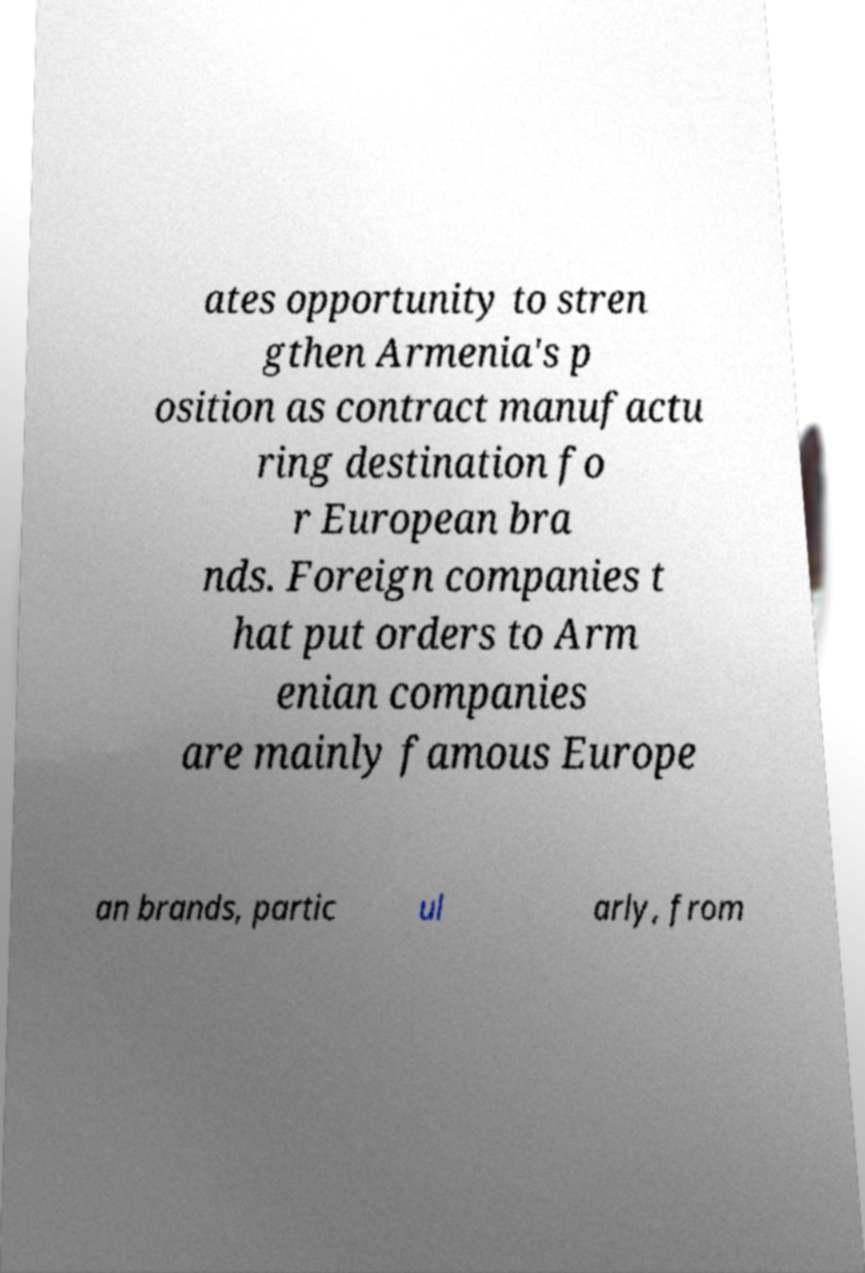Could you extract and type out the text from this image? ates opportunity to stren gthen Armenia's p osition as contract manufactu ring destination fo r European bra nds. Foreign companies t hat put orders to Arm enian companies are mainly famous Europe an brands, partic ul arly, from 